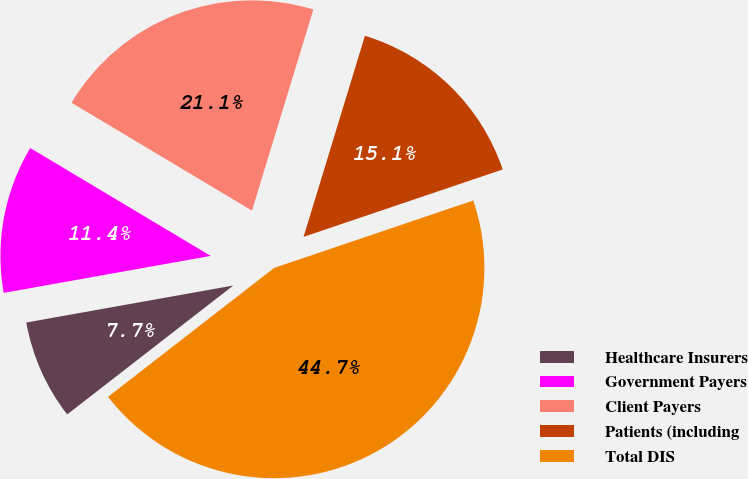Convert chart. <chart><loc_0><loc_0><loc_500><loc_500><pie_chart><fcel>Healthcare Insurers<fcel>Government Payers<fcel>Client Payers<fcel>Patients (including<fcel>Total DIS<nl><fcel>7.69%<fcel>11.39%<fcel>21.14%<fcel>15.09%<fcel>44.69%<nl></chart> 